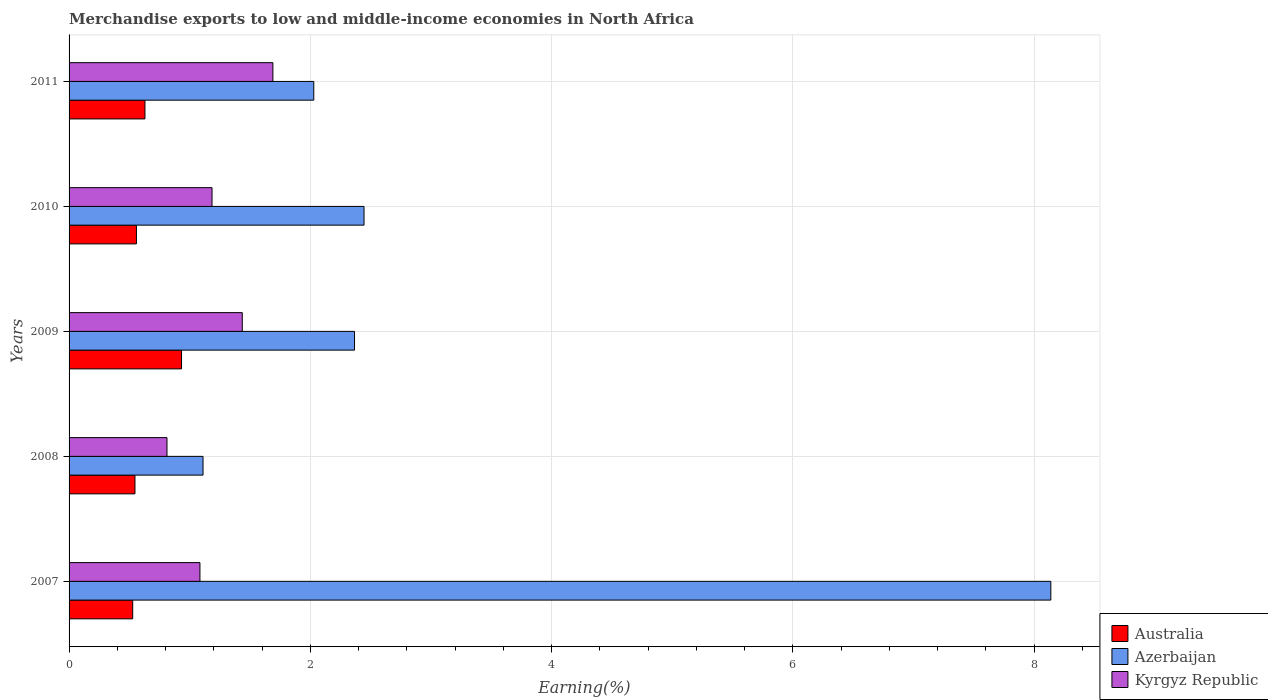How many groups of bars are there?
Offer a very short reply. 5. How many bars are there on the 5th tick from the bottom?
Offer a very short reply. 3. What is the percentage of amount earned from merchandise exports in Australia in 2009?
Make the answer very short. 0.93. Across all years, what is the maximum percentage of amount earned from merchandise exports in Azerbaijan?
Your response must be concise. 8.14. Across all years, what is the minimum percentage of amount earned from merchandise exports in Kyrgyz Republic?
Make the answer very short. 0.81. What is the total percentage of amount earned from merchandise exports in Kyrgyz Republic in the graph?
Give a very brief answer. 6.21. What is the difference between the percentage of amount earned from merchandise exports in Australia in 2007 and that in 2009?
Keep it short and to the point. -0.4. What is the difference between the percentage of amount earned from merchandise exports in Azerbaijan in 2009 and the percentage of amount earned from merchandise exports in Australia in 2008?
Offer a terse response. 1.82. What is the average percentage of amount earned from merchandise exports in Kyrgyz Republic per year?
Provide a short and direct response. 1.24. In the year 2009, what is the difference between the percentage of amount earned from merchandise exports in Australia and percentage of amount earned from merchandise exports in Kyrgyz Republic?
Provide a succinct answer. -0.5. In how many years, is the percentage of amount earned from merchandise exports in Kyrgyz Republic greater than 2.8 %?
Provide a short and direct response. 0. What is the ratio of the percentage of amount earned from merchandise exports in Azerbaijan in 2007 to that in 2011?
Your answer should be compact. 4.01. Is the percentage of amount earned from merchandise exports in Australia in 2009 less than that in 2010?
Provide a succinct answer. No. Is the difference between the percentage of amount earned from merchandise exports in Australia in 2009 and 2011 greater than the difference between the percentage of amount earned from merchandise exports in Kyrgyz Republic in 2009 and 2011?
Your answer should be compact. Yes. What is the difference between the highest and the second highest percentage of amount earned from merchandise exports in Australia?
Your answer should be compact. 0.3. What is the difference between the highest and the lowest percentage of amount earned from merchandise exports in Australia?
Ensure brevity in your answer.  0.4. In how many years, is the percentage of amount earned from merchandise exports in Kyrgyz Republic greater than the average percentage of amount earned from merchandise exports in Kyrgyz Republic taken over all years?
Your answer should be very brief. 2. Is the sum of the percentage of amount earned from merchandise exports in Azerbaijan in 2008 and 2009 greater than the maximum percentage of amount earned from merchandise exports in Australia across all years?
Your answer should be very brief. Yes. What does the 2nd bar from the top in 2011 represents?
Give a very brief answer. Azerbaijan. What does the 1st bar from the bottom in 2011 represents?
Your answer should be compact. Australia. How many bars are there?
Provide a short and direct response. 15. Are all the bars in the graph horizontal?
Your response must be concise. Yes. How many years are there in the graph?
Offer a terse response. 5. Are the values on the major ticks of X-axis written in scientific E-notation?
Your answer should be very brief. No. Does the graph contain grids?
Offer a very short reply. Yes. Where does the legend appear in the graph?
Give a very brief answer. Bottom right. What is the title of the graph?
Give a very brief answer. Merchandise exports to low and middle-income economies in North Africa. What is the label or title of the X-axis?
Make the answer very short. Earning(%). What is the Earning(%) in Australia in 2007?
Your response must be concise. 0.53. What is the Earning(%) in Azerbaijan in 2007?
Provide a succinct answer. 8.14. What is the Earning(%) in Kyrgyz Republic in 2007?
Provide a short and direct response. 1.08. What is the Earning(%) in Australia in 2008?
Keep it short and to the point. 0.55. What is the Earning(%) in Azerbaijan in 2008?
Keep it short and to the point. 1.11. What is the Earning(%) of Kyrgyz Republic in 2008?
Provide a succinct answer. 0.81. What is the Earning(%) in Australia in 2009?
Your response must be concise. 0.93. What is the Earning(%) of Azerbaijan in 2009?
Provide a short and direct response. 2.37. What is the Earning(%) in Kyrgyz Republic in 2009?
Give a very brief answer. 1.44. What is the Earning(%) of Australia in 2010?
Your answer should be very brief. 0.56. What is the Earning(%) of Azerbaijan in 2010?
Your answer should be very brief. 2.44. What is the Earning(%) of Kyrgyz Republic in 2010?
Provide a short and direct response. 1.19. What is the Earning(%) in Australia in 2011?
Provide a succinct answer. 0.63. What is the Earning(%) in Azerbaijan in 2011?
Make the answer very short. 2.03. What is the Earning(%) of Kyrgyz Republic in 2011?
Provide a succinct answer. 1.69. Across all years, what is the maximum Earning(%) of Australia?
Your response must be concise. 0.93. Across all years, what is the maximum Earning(%) of Azerbaijan?
Offer a very short reply. 8.14. Across all years, what is the maximum Earning(%) of Kyrgyz Republic?
Offer a very short reply. 1.69. Across all years, what is the minimum Earning(%) in Australia?
Provide a short and direct response. 0.53. Across all years, what is the minimum Earning(%) of Azerbaijan?
Make the answer very short. 1.11. Across all years, what is the minimum Earning(%) in Kyrgyz Republic?
Your response must be concise. 0.81. What is the total Earning(%) of Australia in the graph?
Provide a short and direct response. 3.19. What is the total Earning(%) in Azerbaijan in the graph?
Your answer should be compact. 16.09. What is the total Earning(%) of Kyrgyz Republic in the graph?
Offer a very short reply. 6.21. What is the difference between the Earning(%) of Australia in 2007 and that in 2008?
Offer a terse response. -0.02. What is the difference between the Earning(%) in Azerbaijan in 2007 and that in 2008?
Offer a very short reply. 7.03. What is the difference between the Earning(%) in Kyrgyz Republic in 2007 and that in 2008?
Provide a short and direct response. 0.27. What is the difference between the Earning(%) in Australia in 2007 and that in 2009?
Provide a short and direct response. -0.4. What is the difference between the Earning(%) of Azerbaijan in 2007 and that in 2009?
Ensure brevity in your answer.  5.77. What is the difference between the Earning(%) of Kyrgyz Republic in 2007 and that in 2009?
Keep it short and to the point. -0.35. What is the difference between the Earning(%) of Australia in 2007 and that in 2010?
Your answer should be very brief. -0.03. What is the difference between the Earning(%) in Azerbaijan in 2007 and that in 2010?
Offer a terse response. 5.69. What is the difference between the Earning(%) in Kyrgyz Republic in 2007 and that in 2010?
Provide a short and direct response. -0.1. What is the difference between the Earning(%) of Australia in 2007 and that in 2011?
Your answer should be very brief. -0.1. What is the difference between the Earning(%) of Azerbaijan in 2007 and that in 2011?
Your response must be concise. 6.11. What is the difference between the Earning(%) of Kyrgyz Republic in 2007 and that in 2011?
Provide a short and direct response. -0.6. What is the difference between the Earning(%) of Australia in 2008 and that in 2009?
Offer a very short reply. -0.39. What is the difference between the Earning(%) in Azerbaijan in 2008 and that in 2009?
Give a very brief answer. -1.26. What is the difference between the Earning(%) of Kyrgyz Republic in 2008 and that in 2009?
Offer a terse response. -0.62. What is the difference between the Earning(%) of Australia in 2008 and that in 2010?
Provide a succinct answer. -0.01. What is the difference between the Earning(%) in Azerbaijan in 2008 and that in 2010?
Keep it short and to the point. -1.33. What is the difference between the Earning(%) of Kyrgyz Republic in 2008 and that in 2010?
Your answer should be very brief. -0.37. What is the difference between the Earning(%) in Australia in 2008 and that in 2011?
Your response must be concise. -0.08. What is the difference between the Earning(%) of Azerbaijan in 2008 and that in 2011?
Your answer should be very brief. -0.92. What is the difference between the Earning(%) in Kyrgyz Republic in 2008 and that in 2011?
Offer a very short reply. -0.88. What is the difference between the Earning(%) of Australia in 2009 and that in 2010?
Provide a succinct answer. 0.37. What is the difference between the Earning(%) of Azerbaijan in 2009 and that in 2010?
Make the answer very short. -0.08. What is the difference between the Earning(%) in Kyrgyz Republic in 2009 and that in 2010?
Give a very brief answer. 0.25. What is the difference between the Earning(%) in Australia in 2009 and that in 2011?
Offer a terse response. 0.3. What is the difference between the Earning(%) in Azerbaijan in 2009 and that in 2011?
Offer a very short reply. 0.34. What is the difference between the Earning(%) in Kyrgyz Republic in 2009 and that in 2011?
Your answer should be very brief. -0.25. What is the difference between the Earning(%) in Australia in 2010 and that in 2011?
Your answer should be compact. -0.07. What is the difference between the Earning(%) of Azerbaijan in 2010 and that in 2011?
Your response must be concise. 0.42. What is the difference between the Earning(%) in Kyrgyz Republic in 2010 and that in 2011?
Keep it short and to the point. -0.5. What is the difference between the Earning(%) in Australia in 2007 and the Earning(%) in Azerbaijan in 2008?
Make the answer very short. -0.58. What is the difference between the Earning(%) in Australia in 2007 and the Earning(%) in Kyrgyz Republic in 2008?
Make the answer very short. -0.28. What is the difference between the Earning(%) in Azerbaijan in 2007 and the Earning(%) in Kyrgyz Republic in 2008?
Provide a succinct answer. 7.33. What is the difference between the Earning(%) in Australia in 2007 and the Earning(%) in Azerbaijan in 2009?
Offer a very short reply. -1.84. What is the difference between the Earning(%) in Australia in 2007 and the Earning(%) in Kyrgyz Republic in 2009?
Offer a very short reply. -0.91. What is the difference between the Earning(%) of Azerbaijan in 2007 and the Earning(%) of Kyrgyz Republic in 2009?
Ensure brevity in your answer.  6.7. What is the difference between the Earning(%) of Australia in 2007 and the Earning(%) of Azerbaijan in 2010?
Keep it short and to the point. -1.92. What is the difference between the Earning(%) of Australia in 2007 and the Earning(%) of Kyrgyz Republic in 2010?
Provide a succinct answer. -0.66. What is the difference between the Earning(%) of Azerbaijan in 2007 and the Earning(%) of Kyrgyz Republic in 2010?
Ensure brevity in your answer.  6.95. What is the difference between the Earning(%) of Australia in 2007 and the Earning(%) of Azerbaijan in 2011?
Your answer should be very brief. -1.5. What is the difference between the Earning(%) of Australia in 2007 and the Earning(%) of Kyrgyz Republic in 2011?
Ensure brevity in your answer.  -1.16. What is the difference between the Earning(%) in Azerbaijan in 2007 and the Earning(%) in Kyrgyz Republic in 2011?
Offer a terse response. 6.45. What is the difference between the Earning(%) of Australia in 2008 and the Earning(%) of Azerbaijan in 2009?
Offer a very short reply. -1.82. What is the difference between the Earning(%) of Australia in 2008 and the Earning(%) of Kyrgyz Republic in 2009?
Provide a short and direct response. -0.89. What is the difference between the Earning(%) of Azerbaijan in 2008 and the Earning(%) of Kyrgyz Republic in 2009?
Your answer should be compact. -0.33. What is the difference between the Earning(%) of Australia in 2008 and the Earning(%) of Azerbaijan in 2010?
Your answer should be compact. -1.9. What is the difference between the Earning(%) of Australia in 2008 and the Earning(%) of Kyrgyz Republic in 2010?
Provide a succinct answer. -0.64. What is the difference between the Earning(%) in Azerbaijan in 2008 and the Earning(%) in Kyrgyz Republic in 2010?
Your answer should be very brief. -0.07. What is the difference between the Earning(%) of Australia in 2008 and the Earning(%) of Azerbaijan in 2011?
Your answer should be very brief. -1.48. What is the difference between the Earning(%) in Australia in 2008 and the Earning(%) in Kyrgyz Republic in 2011?
Your answer should be very brief. -1.14. What is the difference between the Earning(%) in Azerbaijan in 2008 and the Earning(%) in Kyrgyz Republic in 2011?
Offer a very short reply. -0.58. What is the difference between the Earning(%) of Australia in 2009 and the Earning(%) of Azerbaijan in 2010?
Provide a short and direct response. -1.51. What is the difference between the Earning(%) of Australia in 2009 and the Earning(%) of Kyrgyz Republic in 2010?
Give a very brief answer. -0.25. What is the difference between the Earning(%) in Azerbaijan in 2009 and the Earning(%) in Kyrgyz Republic in 2010?
Provide a short and direct response. 1.18. What is the difference between the Earning(%) in Australia in 2009 and the Earning(%) in Azerbaijan in 2011?
Keep it short and to the point. -1.1. What is the difference between the Earning(%) in Australia in 2009 and the Earning(%) in Kyrgyz Republic in 2011?
Ensure brevity in your answer.  -0.76. What is the difference between the Earning(%) in Azerbaijan in 2009 and the Earning(%) in Kyrgyz Republic in 2011?
Give a very brief answer. 0.68. What is the difference between the Earning(%) in Australia in 2010 and the Earning(%) in Azerbaijan in 2011?
Offer a terse response. -1.47. What is the difference between the Earning(%) of Australia in 2010 and the Earning(%) of Kyrgyz Republic in 2011?
Your response must be concise. -1.13. What is the difference between the Earning(%) of Azerbaijan in 2010 and the Earning(%) of Kyrgyz Republic in 2011?
Make the answer very short. 0.76. What is the average Earning(%) in Australia per year?
Give a very brief answer. 0.64. What is the average Earning(%) in Azerbaijan per year?
Your answer should be compact. 3.22. What is the average Earning(%) in Kyrgyz Republic per year?
Provide a succinct answer. 1.24. In the year 2007, what is the difference between the Earning(%) of Australia and Earning(%) of Azerbaijan?
Ensure brevity in your answer.  -7.61. In the year 2007, what is the difference between the Earning(%) in Australia and Earning(%) in Kyrgyz Republic?
Ensure brevity in your answer.  -0.56. In the year 2007, what is the difference between the Earning(%) of Azerbaijan and Earning(%) of Kyrgyz Republic?
Your response must be concise. 7.05. In the year 2008, what is the difference between the Earning(%) in Australia and Earning(%) in Azerbaijan?
Offer a very short reply. -0.56. In the year 2008, what is the difference between the Earning(%) of Australia and Earning(%) of Kyrgyz Republic?
Ensure brevity in your answer.  -0.27. In the year 2008, what is the difference between the Earning(%) in Azerbaijan and Earning(%) in Kyrgyz Republic?
Your answer should be very brief. 0.3. In the year 2009, what is the difference between the Earning(%) of Australia and Earning(%) of Azerbaijan?
Make the answer very short. -1.43. In the year 2009, what is the difference between the Earning(%) of Australia and Earning(%) of Kyrgyz Republic?
Give a very brief answer. -0.5. In the year 2009, what is the difference between the Earning(%) of Azerbaijan and Earning(%) of Kyrgyz Republic?
Keep it short and to the point. 0.93. In the year 2010, what is the difference between the Earning(%) in Australia and Earning(%) in Azerbaijan?
Offer a very short reply. -1.89. In the year 2010, what is the difference between the Earning(%) in Australia and Earning(%) in Kyrgyz Republic?
Give a very brief answer. -0.63. In the year 2010, what is the difference between the Earning(%) in Azerbaijan and Earning(%) in Kyrgyz Republic?
Make the answer very short. 1.26. In the year 2011, what is the difference between the Earning(%) of Australia and Earning(%) of Azerbaijan?
Make the answer very short. -1.4. In the year 2011, what is the difference between the Earning(%) of Australia and Earning(%) of Kyrgyz Republic?
Provide a short and direct response. -1.06. In the year 2011, what is the difference between the Earning(%) in Azerbaijan and Earning(%) in Kyrgyz Republic?
Make the answer very short. 0.34. What is the ratio of the Earning(%) in Australia in 2007 to that in 2008?
Offer a very short reply. 0.97. What is the ratio of the Earning(%) in Azerbaijan in 2007 to that in 2008?
Ensure brevity in your answer.  7.33. What is the ratio of the Earning(%) of Kyrgyz Republic in 2007 to that in 2008?
Give a very brief answer. 1.34. What is the ratio of the Earning(%) of Australia in 2007 to that in 2009?
Ensure brevity in your answer.  0.57. What is the ratio of the Earning(%) in Azerbaijan in 2007 to that in 2009?
Your answer should be very brief. 3.44. What is the ratio of the Earning(%) in Kyrgyz Republic in 2007 to that in 2009?
Your answer should be compact. 0.76. What is the ratio of the Earning(%) in Australia in 2007 to that in 2010?
Your response must be concise. 0.94. What is the ratio of the Earning(%) in Azerbaijan in 2007 to that in 2010?
Keep it short and to the point. 3.33. What is the ratio of the Earning(%) in Kyrgyz Republic in 2007 to that in 2010?
Your response must be concise. 0.92. What is the ratio of the Earning(%) in Australia in 2007 to that in 2011?
Your answer should be very brief. 0.84. What is the ratio of the Earning(%) in Azerbaijan in 2007 to that in 2011?
Keep it short and to the point. 4.01. What is the ratio of the Earning(%) of Kyrgyz Republic in 2007 to that in 2011?
Your answer should be very brief. 0.64. What is the ratio of the Earning(%) of Australia in 2008 to that in 2009?
Provide a short and direct response. 0.59. What is the ratio of the Earning(%) of Azerbaijan in 2008 to that in 2009?
Your answer should be compact. 0.47. What is the ratio of the Earning(%) of Kyrgyz Republic in 2008 to that in 2009?
Provide a short and direct response. 0.57. What is the ratio of the Earning(%) of Australia in 2008 to that in 2010?
Keep it short and to the point. 0.98. What is the ratio of the Earning(%) in Azerbaijan in 2008 to that in 2010?
Your answer should be compact. 0.45. What is the ratio of the Earning(%) in Kyrgyz Republic in 2008 to that in 2010?
Offer a terse response. 0.68. What is the ratio of the Earning(%) in Australia in 2008 to that in 2011?
Give a very brief answer. 0.87. What is the ratio of the Earning(%) in Azerbaijan in 2008 to that in 2011?
Make the answer very short. 0.55. What is the ratio of the Earning(%) in Kyrgyz Republic in 2008 to that in 2011?
Keep it short and to the point. 0.48. What is the ratio of the Earning(%) in Australia in 2009 to that in 2010?
Your response must be concise. 1.67. What is the ratio of the Earning(%) of Azerbaijan in 2009 to that in 2010?
Your response must be concise. 0.97. What is the ratio of the Earning(%) of Kyrgyz Republic in 2009 to that in 2010?
Offer a very short reply. 1.21. What is the ratio of the Earning(%) of Australia in 2009 to that in 2011?
Offer a terse response. 1.48. What is the ratio of the Earning(%) in Azerbaijan in 2009 to that in 2011?
Ensure brevity in your answer.  1.17. What is the ratio of the Earning(%) in Kyrgyz Republic in 2009 to that in 2011?
Offer a terse response. 0.85. What is the ratio of the Earning(%) in Australia in 2010 to that in 2011?
Your answer should be compact. 0.89. What is the ratio of the Earning(%) in Azerbaijan in 2010 to that in 2011?
Provide a succinct answer. 1.21. What is the ratio of the Earning(%) of Kyrgyz Republic in 2010 to that in 2011?
Make the answer very short. 0.7. What is the difference between the highest and the second highest Earning(%) in Australia?
Provide a short and direct response. 0.3. What is the difference between the highest and the second highest Earning(%) in Azerbaijan?
Your response must be concise. 5.69. What is the difference between the highest and the second highest Earning(%) in Kyrgyz Republic?
Keep it short and to the point. 0.25. What is the difference between the highest and the lowest Earning(%) of Australia?
Your answer should be very brief. 0.4. What is the difference between the highest and the lowest Earning(%) of Azerbaijan?
Your response must be concise. 7.03. What is the difference between the highest and the lowest Earning(%) in Kyrgyz Republic?
Ensure brevity in your answer.  0.88. 